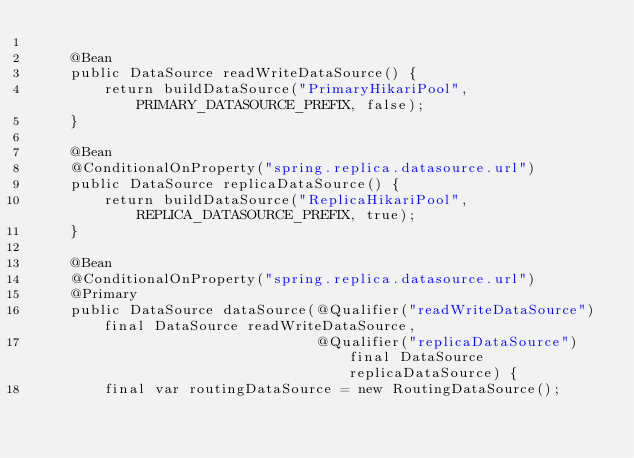<code> <loc_0><loc_0><loc_500><loc_500><_Java_>
    @Bean
    public DataSource readWriteDataSource() {
        return buildDataSource("PrimaryHikariPool", PRIMARY_DATASOURCE_PREFIX, false);
    }

    @Bean
    @ConditionalOnProperty("spring.replica.datasource.url")
    public DataSource replicaDataSource() {
        return buildDataSource("ReplicaHikariPool", REPLICA_DATASOURCE_PREFIX, true);
    }

    @Bean
    @ConditionalOnProperty("spring.replica.datasource.url")
    @Primary
    public DataSource dataSource(@Qualifier("readWriteDataSource") final DataSource readWriteDataSource,
                                 @Qualifier("replicaDataSource") final DataSource replicaDataSource) {
        final var routingDataSource = new RoutingDataSource();</code> 